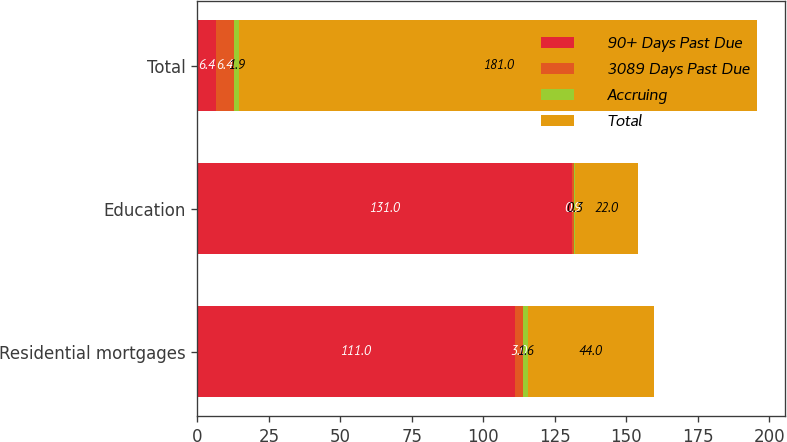Convert chart to OTSL. <chart><loc_0><loc_0><loc_500><loc_500><stacked_bar_chart><ecel><fcel>Residential mortgages<fcel>Education<fcel>Total<nl><fcel>90+ Days Past Due<fcel>111<fcel>131<fcel>6.4<nl><fcel>3089 Days Past Due<fcel>3<fcel>0.9<fcel>6.4<nl><fcel>Accruing<fcel>1.6<fcel>0.3<fcel>1.9<nl><fcel>Total<fcel>44<fcel>22<fcel>181<nl></chart> 